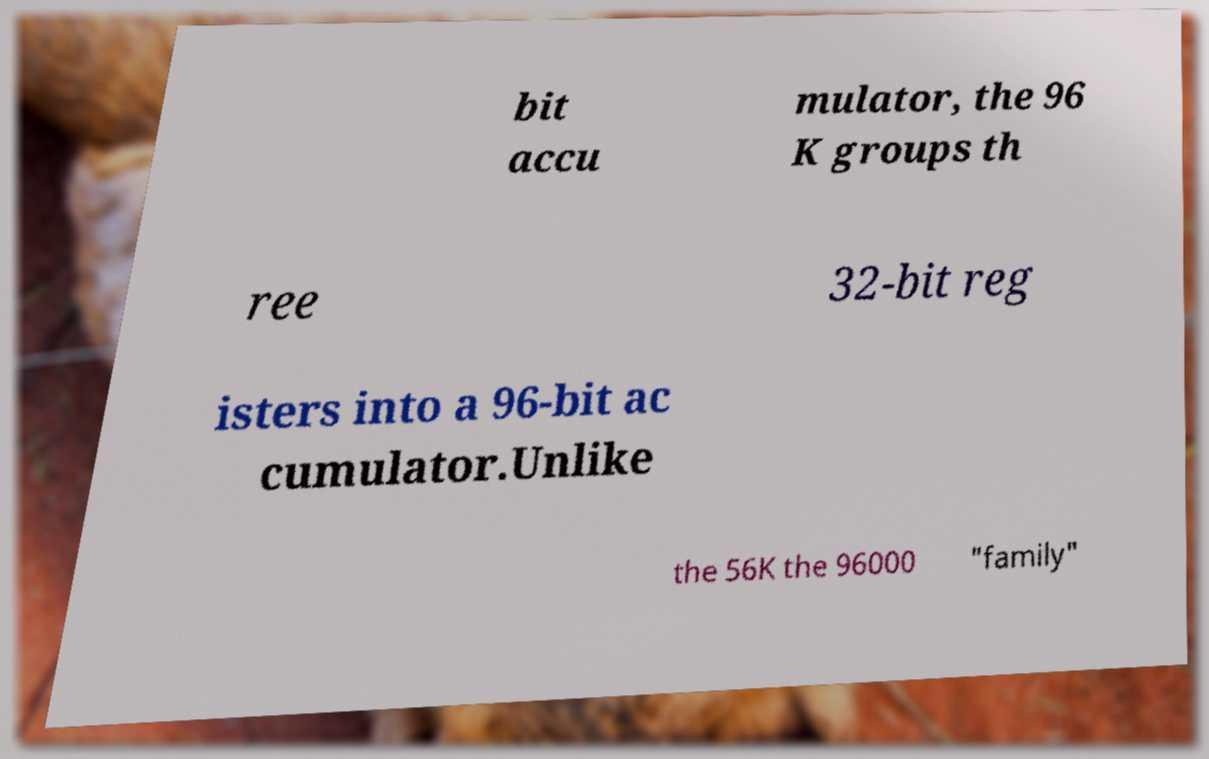There's text embedded in this image that I need extracted. Can you transcribe it verbatim? bit accu mulator, the 96 K groups th ree 32-bit reg isters into a 96-bit ac cumulator.Unlike the 56K the 96000 "family" 